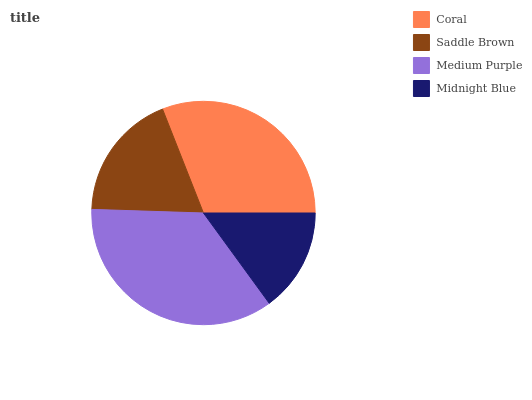Is Midnight Blue the minimum?
Answer yes or no. Yes. Is Medium Purple the maximum?
Answer yes or no. Yes. Is Saddle Brown the minimum?
Answer yes or no. No. Is Saddle Brown the maximum?
Answer yes or no. No. Is Coral greater than Saddle Brown?
Answer yes or no. Yes. Is Saddle Brown less than Coral?
Answer yes or no. Yes. Is Saddle Brown greater than Coral?
Answer yes or no. No. Is Coral less than Saddle Brown?
Answer yes or no. No. Is Coral the high median?
Answer yes or no. Yes. Is Saddle Brown the low median?
Answer yes or no. Yes. Is Midnight Blue the high median?
Answer yes or no. No. Is Medium Purple the low median?
Answer yes or no. No. 